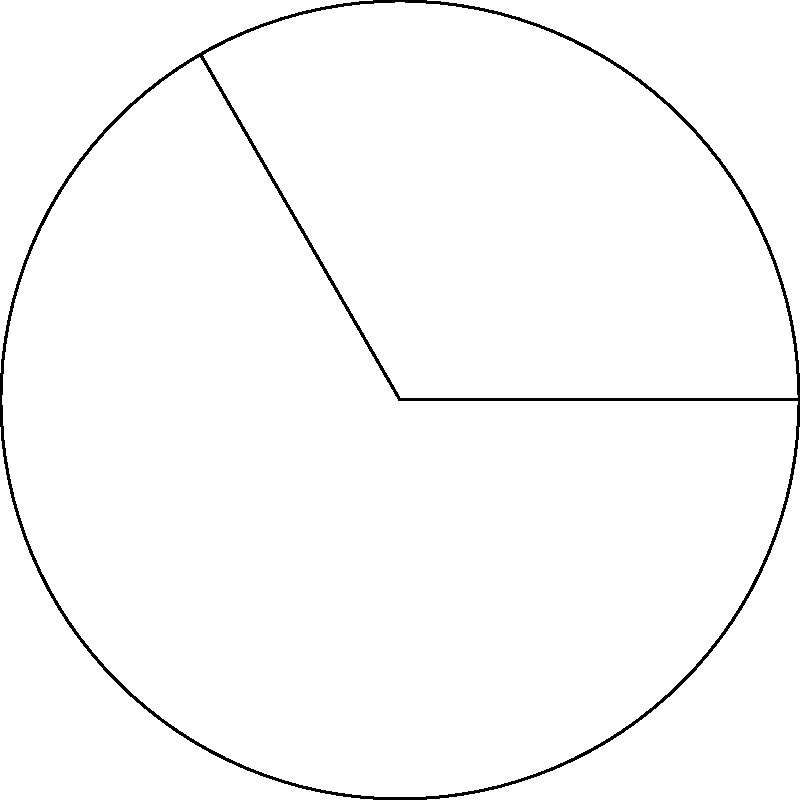In a pediatric ward, a curved corridor forms an arc of a circular floor plan. The radius of the floor plan is 15 meters, and the corridor spans an angle of 120° at the center. What is the length of the curved corridor to the nearest meter? To solve this problem, we need to use the formula for arc length:

Arc Length = $\frac{\theta}{360°} \cdot 2\pi r$

Where:
$\theta$ is the central angle in degrees
$r$ is the radius of the circle

Given:
- Radius (r) = 15 meters
- Central angle ($\theta$) = 120°

Step 1: Substitute the values into the formula
Arc Length = $\frac{120°}{360°} \cdot 2\pi \cdot 15$

Step 2: Simplify the fraction
Arc Length = $\frac{1}{3} \cdot 2\pi \cdot 15$

Step 3: Calculate
Arc Length = $\frac{1}{3} \cdot 2 \cdot \pi \cdot 15$
           = $10\pi$ meters

Step 4: Calculate the value of $10\pi$
Arc Length ≈ 31.4159 meters

Step 5: Round to the nearest meter
Arc Length ≈ 31 meters
Answer: 31 meters 